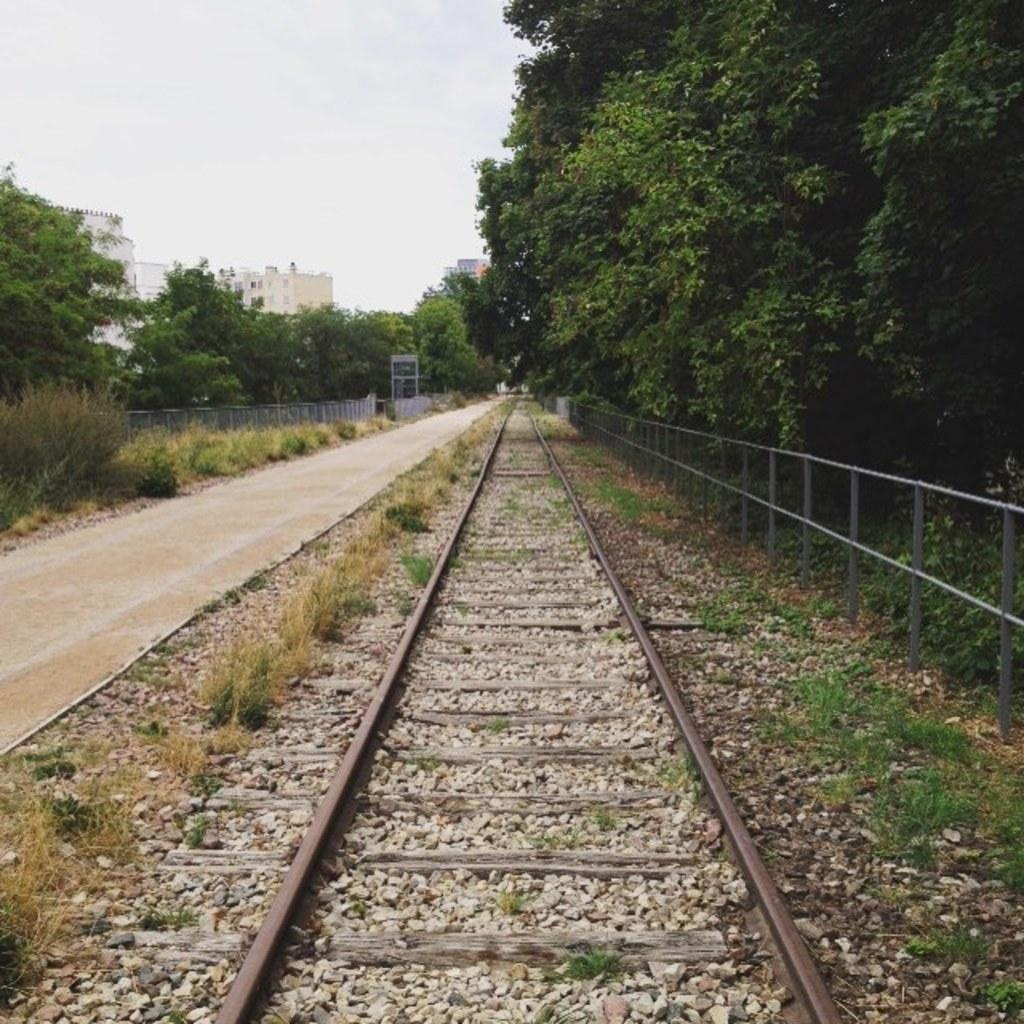What is the main element in the center of the image? There is sky in the center of the image. What can be seen in the sky? Clouds are present in the image. What type of structures are visible in the image? There are buildings in the image. What type of vegetation is present in the image? Trees and plants are visible in the image. What type of ground cover is present in the image? Grass is present in the image. What type of barriers are in the image? Fences are in the image. What type of natural elements are present in the image? Stones are present in the image. What man-made structures are present in the image? There is a road and a railway track in the image. What type of credit can be seen being exchanged between the trees in the image? There is no credit being exchanged in the image; it is a landscape scene with trees, plants, and other natural elements. 